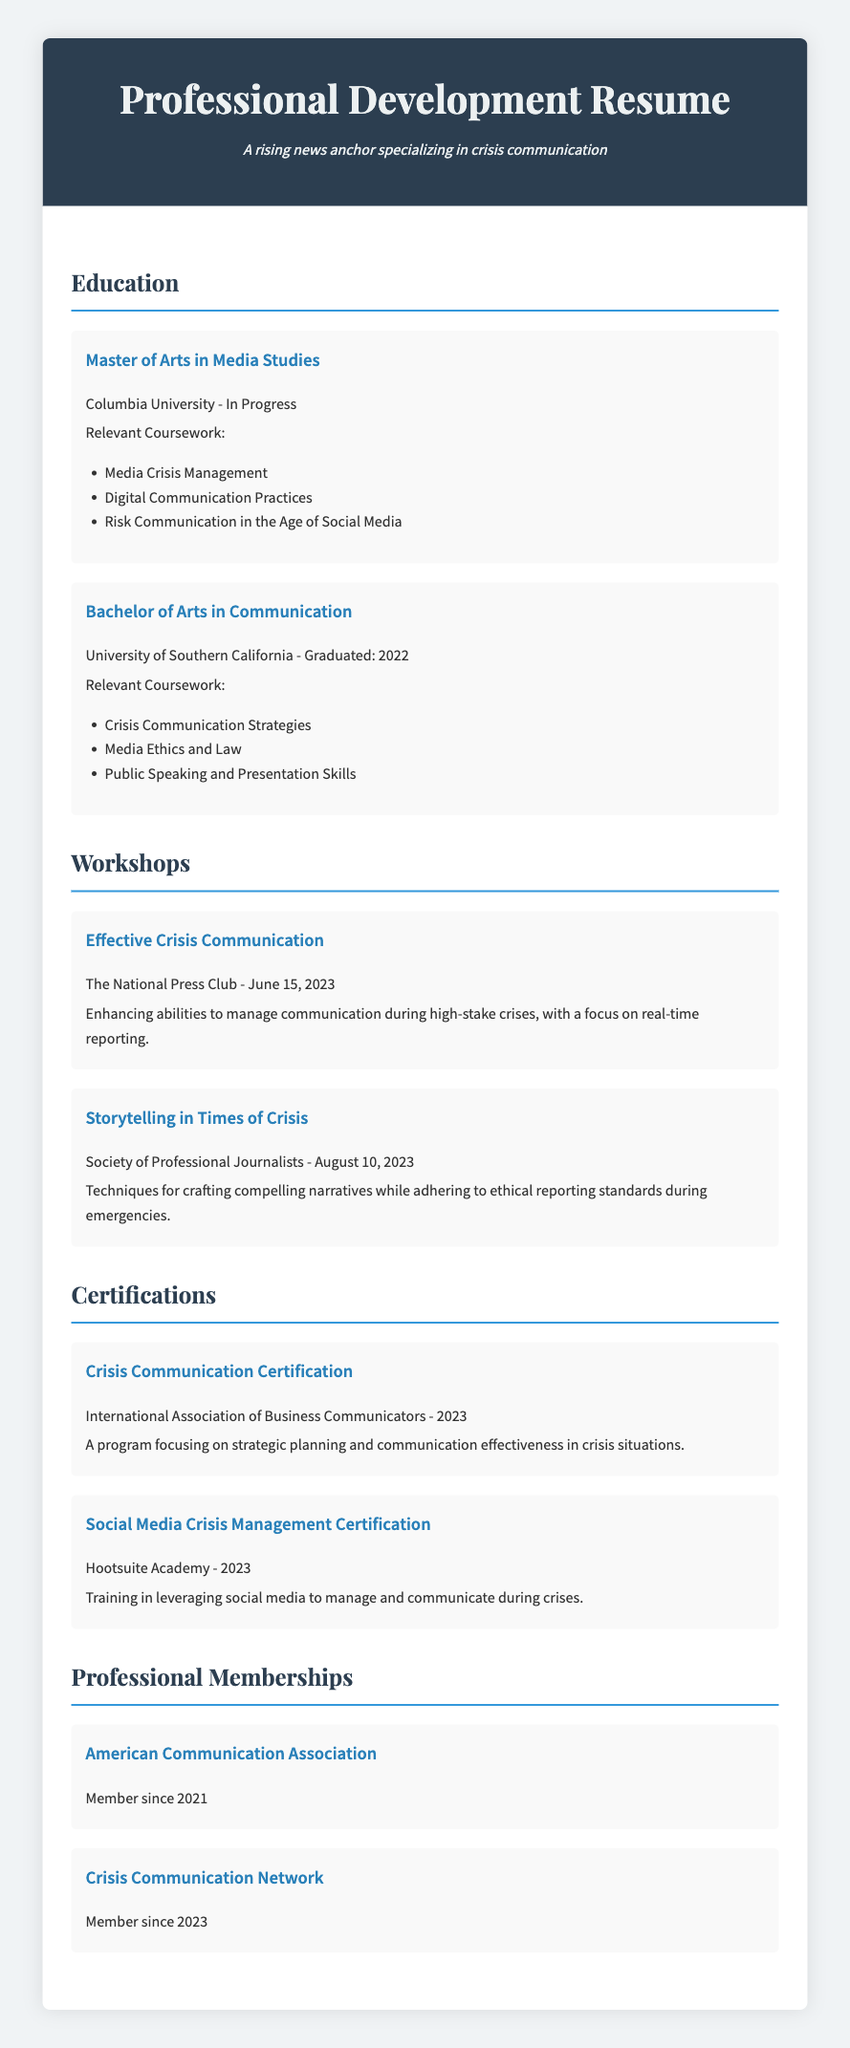What is the degree mentioned in the education section? The degree mentioned is identified in the education section of the document.
Answer: Master of Arts in Media Studies Which university is the ongoing degree from? The university offering the ongoing degree is specified in the document.
Answer: Columbia University What workshop was held on June 15, 2023? The document lists workshops with their respective dates, allowing for identification of the specific workshop.
Answer: Effective Crisis Communication How many relevant courses are listed for the Bachelor's degree? The total number of relevant courses for the Bachelor's degree can be counted from the list provided in the document.
Answer: Three What certification was obtained in 2023? The document explicitly mentions the certifications acquired, particularly the one from 2023.
Answer: Crisis Communication Certification Which organization held the "Storytelling in Times of Crisis" workshop? The organization providing the workshop can be found in the document under the workshops section.
Answer: Society of Professional Journalists How long has the individual been a member of the American Communication Association? The duration can be inferred from the member since date listed in the document.
Answer: Since 2021 What is the main focus of the "Social Media Crisis Management Certification"? This certification's emphasis can be derived from its description in the document.
Answer: Managing and communicating during crises How many workshops are listed in total? The total count of workshops can be determined by counting the entries under the workshops section.
Answer: Two 